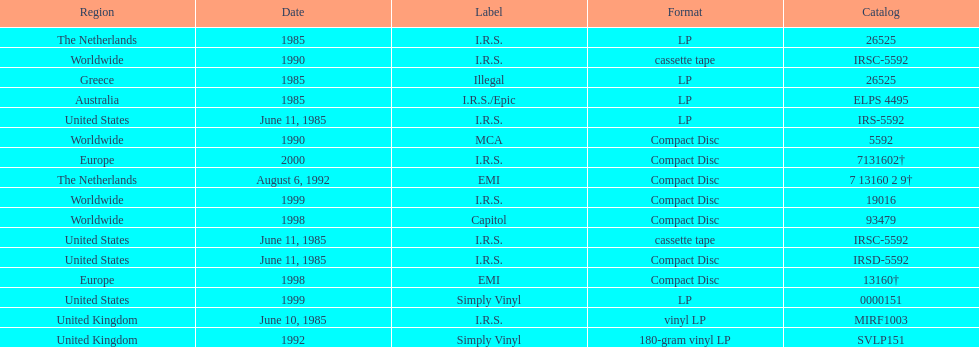How many more releases were in compact disc format than cassette tape? 5. 